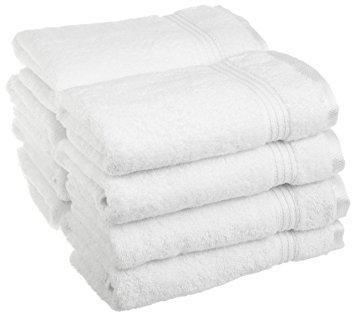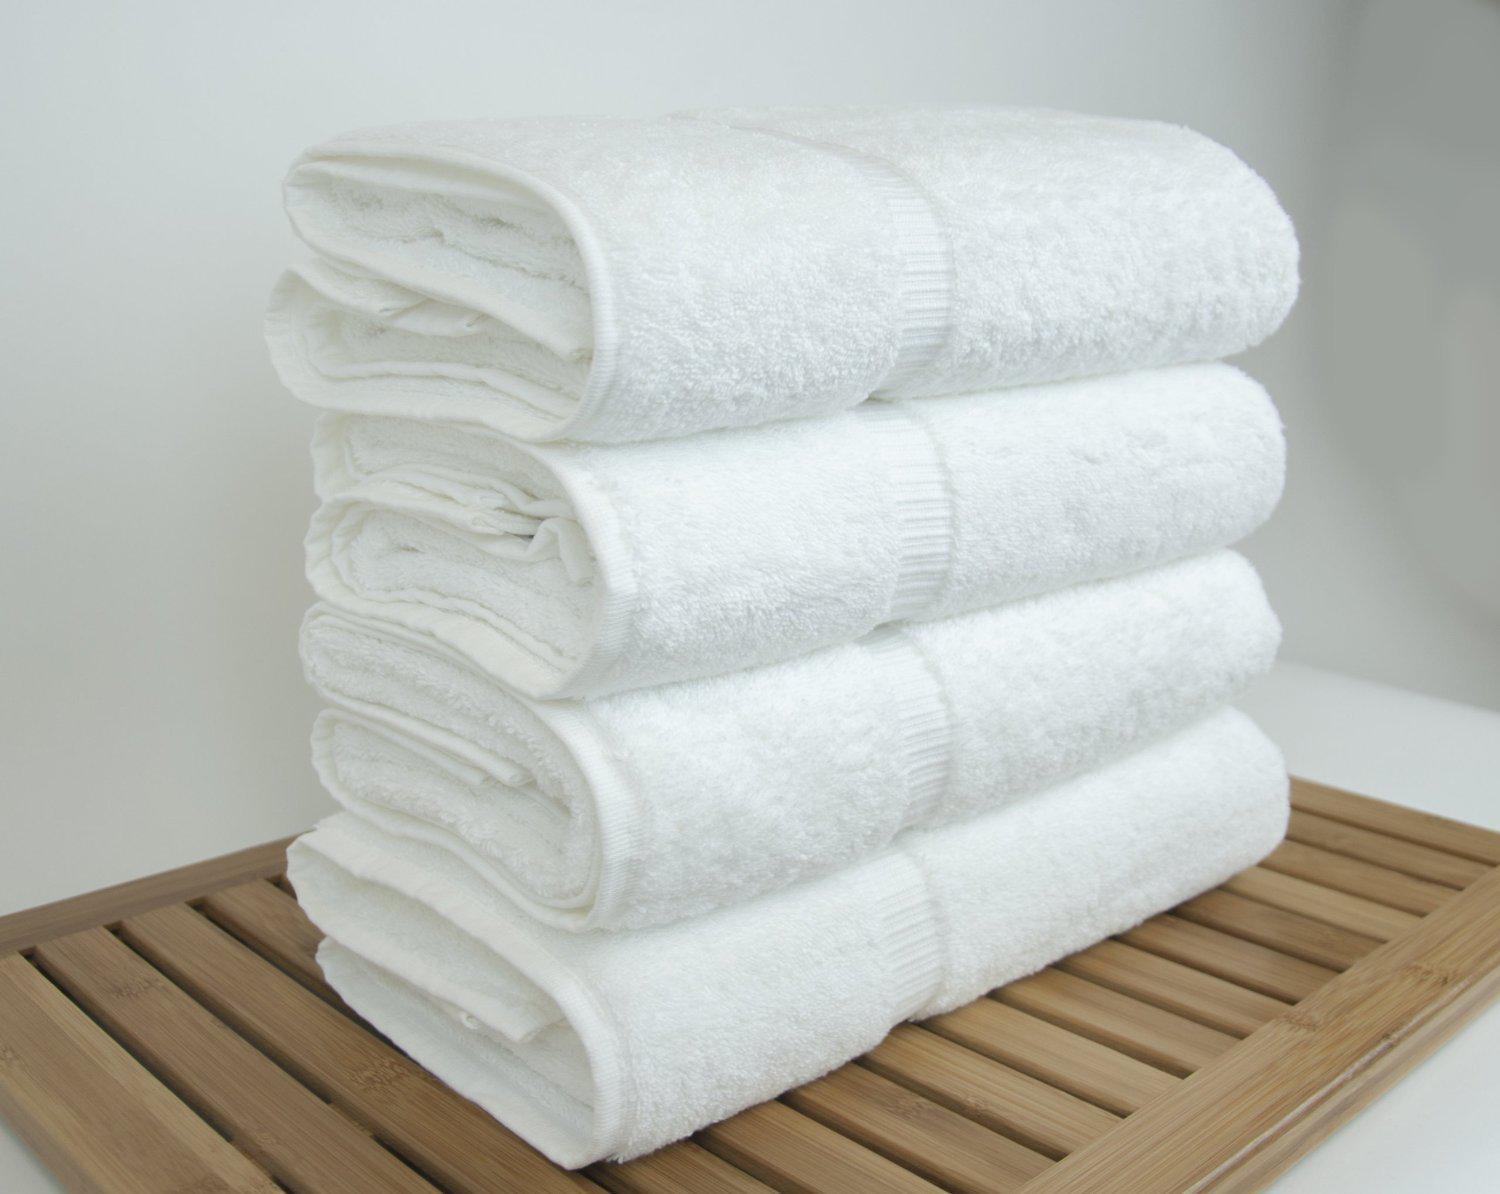The first image is the image on the left, the second image is the image on the right. For the images displayed, is the sentence "There are exactly six folded items in the image on the right." factually correct? Answer yes or no. No. 